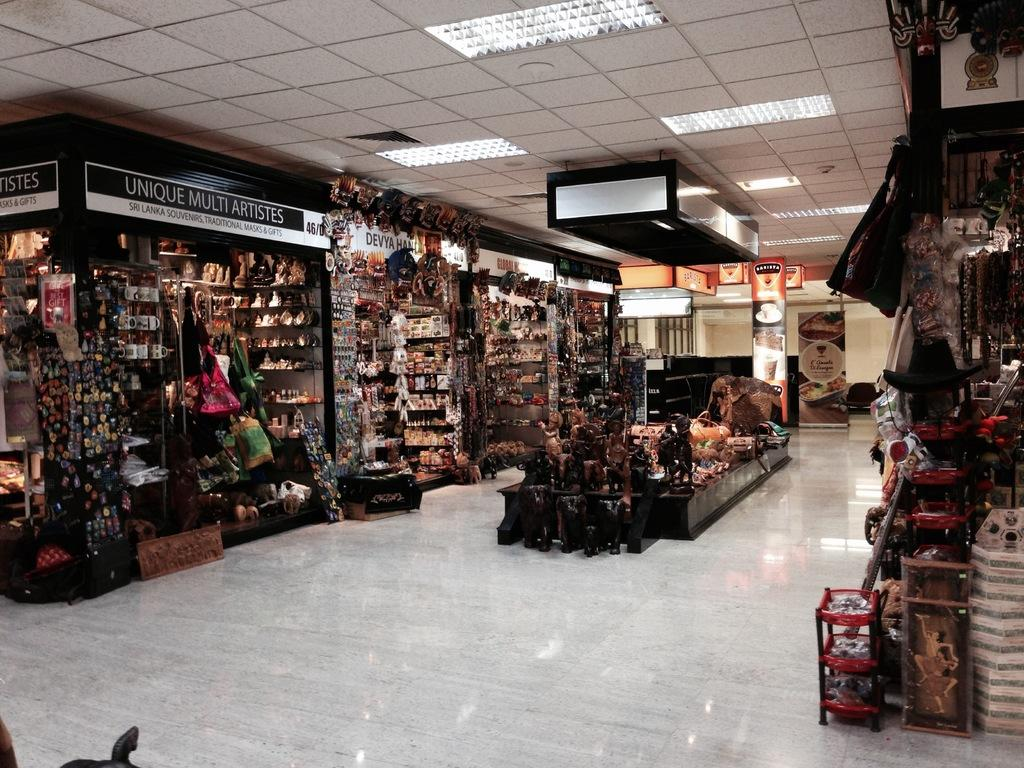What type of structures can be seen in the image? There are shops in the image. How are the shops arranged in the image? The shops are placed in one building. What type of cracker is being sold in the shops in the image? There is no indication of any specific items being sold in the shops in the image, including crackers. 